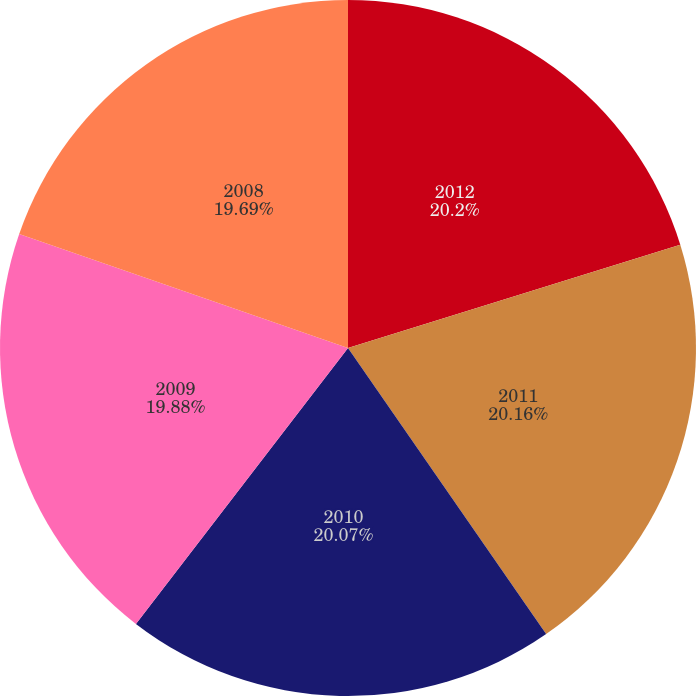Convert chart to OTSL. <chart><loc_0><loc_0><loc_500><loc_500><pie_chart><fcel>2012<fcel>2011<fcel>2010<fcel>2009<fcel>2008<nl><fcel>20.2%<fcel>20.16%<fcel>20.07%<fcel>19.88%<fcel>19.69%<nl></chart> 